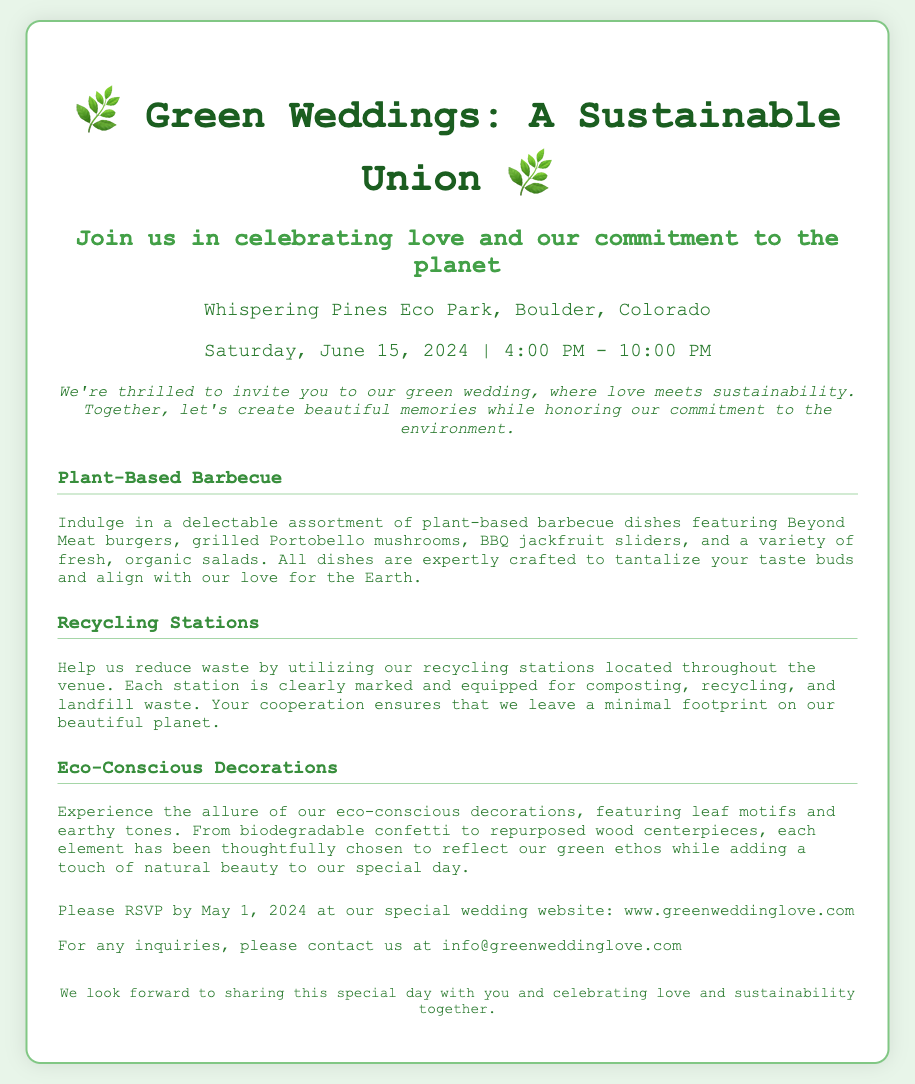What is the date of the wedding? The wedding is scheduled for June 15, 2024, as mentioned in the event details.
Answer: June 15, 2024 Where is the wedding taking place? The location of the wedding is specified as Whispering Pines Eco Park, Boulder, Colorado.
Answer: Whispering Pines Eco Park, Boulder, Colorado What type of cuisine will be served? The document states that the wedding will feature a plant-based barbecue, highlighting a commitment to sustainability.
Answer: Plant-based barbecue When is the RSVP deadline? The invitation indicates that guests should RSVP by May 1, 2024.
Answer: May 1, 2024 What is highlighted as part of the eco-friendly practices at the wedding? The invitation mentions recycling stations to reduce waste as a key eco-friendly practice during the event.
Answer: Recycling stations How are the decorations described? The decorations are described as eco-conscious with leaf motifs and earthy tones.
Answer: Eco-conscious decorations, leaf motifs, earthy tones What online resource can guests visit for more information? Guests are directed to visit the wedding website for further details and RSVPs.
Answer: www.greenweddinglove.com What type of meat alternatives are mentioned? The document lists Beyond Meat burgers as one of the plant-based options available at the barbecue.
Answer: Beyond Meat burgers 